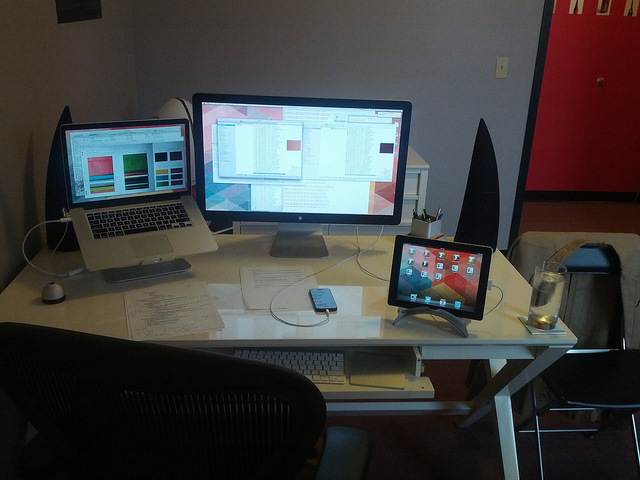How many computers are on the desk? There are two computers visible on the desk: a MacBook laptop and an iMac desktop with a connected second monitor. Additionally, there's an iPad that may contribute to the computing power on the desk. 